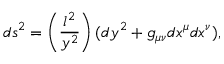<formula> <loc_0><loc_0><loc_500><loc_500>d s ^ { 2 } = \left ( \frac { l ^ { 2 } } { y ^ { 2 } } \right ) ( d y ^ { 2 } + g _ { \mu \nu } d x ^ { \mu } d x ^ { \nu } ) ,</formula> 